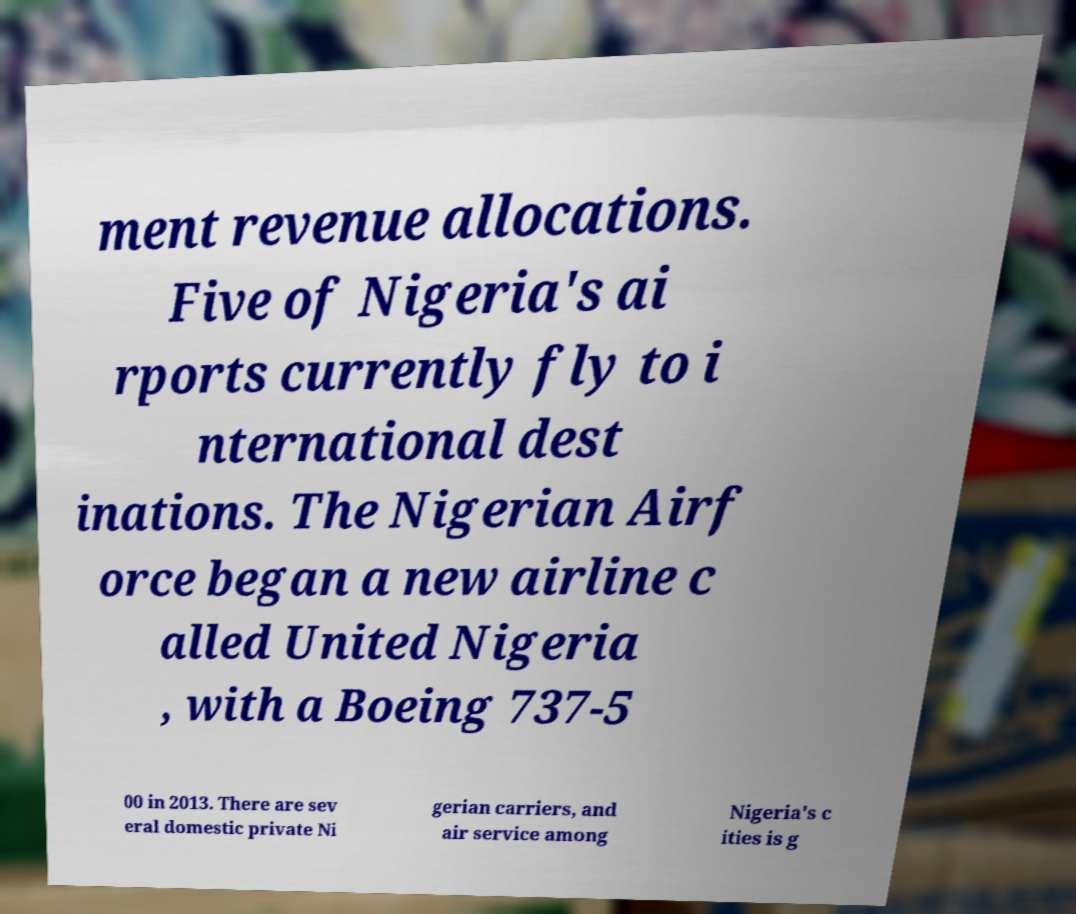For documentation purposes, I need the text within this image transcribed. Could you provide that? ment revenue allocations. Five of Nigeria's ai rports currently fly to i nternational dest inations. The Nigerian Airf orce began a new airline c alled United Nigeria , with a Boeing 737-5 00 in 2013. There are sev eral domestic private Ni gerian carriers, and air service among Nigeria's c ities is g 